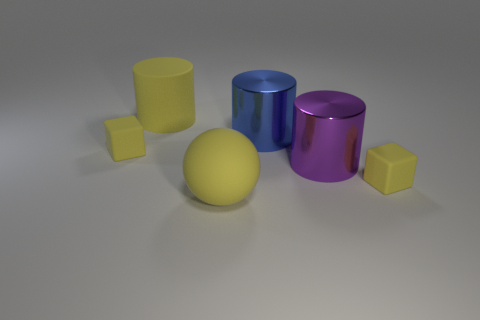Add 2 metallic balls. How many objects exist? 8 Subtract all spheres. How many objects are left? 5 Add 2 tiny matte objects. How many tiny matte objects are left? 4 Add 3 small matte cubes. How many small matte cubes exist? 5 Subtract 1 yellow cylinders. How many objects are left? 5 Subtract all purple things. Subtract all large purple metal cylinders. How many objects are left? 4 